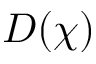<formula> <loc_0><loc_0><loc_500><loc_500>D ( \chi )</formula> 